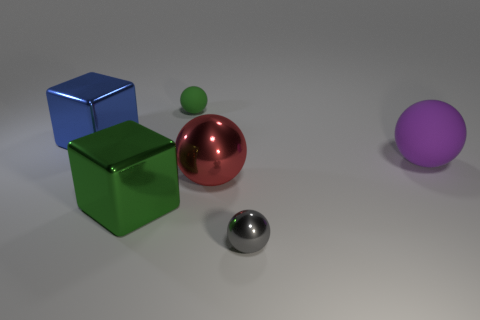Subtract all large matte balls. How many balls are left? 3 Add 2 gray objects. How many objects exist? 8 Subtract all purple spheres. How many spheres are left? 3 Subtract all blocks. How many objects are left? 4 Subtract all blocks. Subtract all small brown cubes. How many objects are left? 4 Add 3 red metal balls. How many red metal balls are left? 4 Add 3 big green cubes. How many big green cubes exist? 4 Subtract 1 blue cubes. How many objects are left? 5 Subtract all green spheres. Subtract all brown blocks. How many spheres are left? 3 